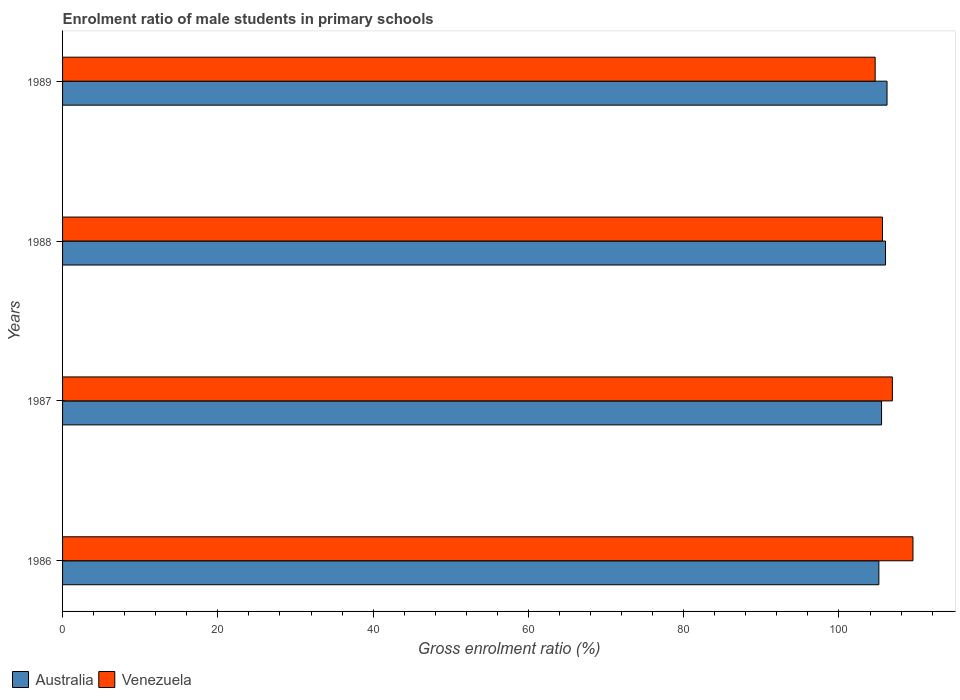How many bars are there on the 2nd tick from the bottom?
Keep it short and to the point. 2. What is the enrolment ratio of male students in primary schools in Australia in 1989?
Your response must be concise. 106.19. Across all years, what is the maximum enrolment ratio of male students in primary schools in Venezuela?
Your response must be concise. 109.53. Across all years, what is the minimum enrolment ratio of male students in primary schools in Australia?
Make the answer very short. 105.14. In which year was the enrolment ratio of male students in primary schools in Australia maximum?
Offer a very short reply. 1989. In which year was the enrolment ratio of male students in primary schools in Venezuela minimum?
Give a very brief answer. 1989. What is the total enrolment ratio of male students in primary schools in Venezuela in the graph?
Your response must be concise. 426.68. What is the difference between the enrolment ratio of male students in primary schools in Australia in 1986 and that in 1988?
Ensure brevity in your answer.  -0.86. What is the difference between the enrolment ratio of male students in primary schools in Australia in 1989 and the enrolment ratio of male students in primary schools in Venezuela in 1986?
Your answer should be compact. -3.34. What is the average enrolment ratio of male students in primary schools in Venezuela per year?
Offer a very short reply. 106.67. In the year 1988, what is the difference between the enrolment ratio of male students in primary schools in Venezuela and enrolment ratio of male students in primary schools in Australia?
Your response must be concise. -0.39. In how many years, is the enrolment ratio of male students in primary schools in Australia greater than 68 %?
Give a very brief answer. 4. What is the ratio of the enrolment ratio of male students in primary schools in Australia in 1986 to that in 1987?
Your answer should be very brief. 1. Is the enrolment ratio of male students in primary schools in Australia in 1986 less than that in 1989?
Keep it short and to the point. Yes. Is the difference between the enrolment ratio of male students in primary schools in Venezuela in 1987 and 1989 greater than the difference between the enrolment ratio of male students in primary schools in Australia in 1987 and 1989?
Give a very brief answer. Yes. What is the difference between the highest and the second highest enrolment ratio of male students in primary schools in Australia?
Make the answer very short. 0.2. What is the difference between the highest and the lowest enrolment ratio of male students in primary schools in Venezuela?
Give a very brief answer. 4.87. What does the 1st bar from the top in 1988 represents?
Offer a terse response. Venezuela. How many bars are there?
Provide a succinct answer. 8. Are all the bars in the graph horizontal?
Offer a very short reply. Yes. What is the difference between two consecutive major ticks on the X-axis?
Offer a terse response. 20. Are the values on the major ticks of X-axis written in scientific E-notation?
Your response must be concise. No. Does the graph contain grids?
Provide a short and direct response. No. How many legend labels are there?
Ensure brevity in your answer.  2. How are the legend labels stacked?
Your response must be concise. Horizontal. What is the title of the graph?
Your response must be concise. Enrolment ratio of male students in primary schools. Does "Japan" appear as one of the legend labels in the graph?
Offer a very short reply. No. What is the label or title of the X-axis?
Make the answer very short. Gross enrolment ratio (%). What is the Gross enrolment ratio (%) of Australia in 1986?
Offer a very short reply. 105.14. What is the Gross enrolment ratio (%) in Venezuela in 1986?
Make the answer very short. 109.53. What is the Gross enrolment ratio (%) in Australia in 1987?
Offer a very short reply. 105.49. What is the Gross enrolment ratio (%) in Venezuela in 1987?
Keep it short and to the point. 106.88. What is the Gross enrolment ratio (%) of Australia in 1988?
Offer a very short reply. 105.99. What is the Gross enrolment ratio (%) in Venezuela in 1988?
Provide a succinct answer. 105.6. What is the Gross enrolment ratio (%) in Australia in 1989?
Make the answer very short. 106.19. What is the Gross enrolment ratio (%) of Venezuela in 1989?
Provide a short and direct response. 104.66. Across all years, what is the maximum Gross enrolment ratio (%) of Australia?
Ensure brevity in your answer.  106.19. Across all years, what is the maximum Gross enrolment ratio (%) in Venezuela?
Your response must be concise. 109.53. Across all years, what is the minimum Gross enrolment ratio (%) in Australia?
Your answer should be compact. 105.14. Across all years, what is the minimum Gross enrolment ratio (%) in Venezuela?
Provide a short and direct response. 104.66. What is the total Gross enrolment ratio (%) of Australia in the graph?
Offer a terse response. 422.81. What is the total Gross enrolment ratio (%) in Venezuela in the graph?
Give a very brief answer. 426.68. What is the difference between the Gross enrolment ratio (%) of Australia in 1986 and that in 1987?
Offer a terse response. -0.35. What is the difference between the Gross enrolment ratio (%) in Venezuela in 1986 and that in 1987?
Offer a terse response. 2.65. What is the difference between the Gross enrolment ratio (%) of Australia in 1986 and that in 1988?
Offer a terse response. -0.86. What is the difference between the Gross enrolment ratio (%) of Venezuela in 1986 and that in 1988?
Provide a succinct answer. 3.93. What is the difference between the Gross enrolment ratio (%) of Australia in 1986 and that in 1989?
Your answer should be very brief. -1.05. What is the difference between the Gross enrolment ratio (%) of Venezuela in 1986 and that in 1989?
Offer a very short reply. 4.87. What is the difference between the Gross enrolment ratio (%) of Australia in 1987 and that in 1988?
Offer a terse response. -0.51. What is the difference between the Gross enrolment ratio (%) of Venezuela in 1987 and that in 1988?
Offer a terse response. 1.27. What is the difference between the Gross enrolment ratio (%) of Australia in 1987 and that in 1989?
Provide a short and direct response. -0.7. What is the difference between the Gross enrolment ratio (%) in Venezuela in 1987 and that in 1989?
Provide a succinct answer. 2.22. What is the difference between the Gross enrolment ratio (%) of Australia in 1988 and that in 1989?
Your response must be concise. -0.2. What is the difference between the Gross enrolment ratio (%) of Venezuela in 1988 and that in 1989?
Your answer should be compact. 0.94. What is the difference between the Gross enrolment ratio (%) of Australia in 1986 and the Gross enrolment ratio (%) of Venezuela in 1987?
Your answer should be compact. -1.74. What is the difference between the Gross enrolment ratio (%) of Australia in 1986 and the Gross enrolment ratio (%) of Venezuela in 1988?
Your response must be concise. -0.46. What is the difference between the Gross enrolment ratio (%) of Australia in 1986 and the Gross enrolment ratio (%) of Venezuela in 1989?
Make the answer very short. 0.48. What is the difference between the Gross enrolment ratio (%) in Australia in 1987 and the Gross enrolment ratio (%) in Venezuela in 1988?
Keep it short and to the point. -0.12. What is the difference between the Gross enrolment ratio (%) of Australia in 1987 and the Gross enrolment ratio (%) of Venezuela in 1989?
Your response must be concise. 0.83. What is the difference between the Gross enrolment ratio (%) in Australia in 1988 and the Gross enrolment ratio (%) in Venezuela in 1989?
Give a very brief answer. 1.33. What is the average Gross enrolment ratio (%) of Australia per year?
Make the answer very short. 105.7. What is the average Gross enrolment ratio (%) of Venezuela per year?
Give a very brief answer. 106.67. In the year 1986, what is the difference between the Gross enrolment ratio (%) of Australia and Gross enrolment ratio (%) of Venezuela?
Ensure brevity in your answer.  -4.39. In the year 1987, what is the difference between the Gross enrolment ratio (%) of Australia and Gross enrolment ratio (%) of Venezuela?
Offer a very short reply. -1.39. In the year 1988, what is the difference between the Gross enrolment ratio (%) of Australia and Gross enrolment ratio (%) of Venezuela?
Give a very brief answer. 0.39. In the year 1989, what is the difference between the Gross enrolment ratio (%) of Australia and Gross enrolment ratio (%) of Venezuela?
Provide a succinct answer. 1.53. What is the ratio of the Gross enrolment ratio (%) of Venezuela in 1986 to that in 1987?
Your answer should be compact. 1.02. What is the ratio of the Gross enrolment ratio (%) of Venezuela in 1986 to that in 1988?
Your answer should be compact. 1.04. What is the ratio of the Gross enrolment ratio (%) in Australia in 1986 to that in 1989?
Your answer should be very brief. 0.99. What is the ratio of the Gross enrolment ratio (%) in Venezuela in 1986 to that in 1989?
Your response must be concise. 1.05. What is the ratio of the Gross enrolment ratio (%) in Australia in 1987 to that in 1988?
Offer a very short reply. 1. What is the ratio of the Gross enrolment ratio (%) in Venezuela in 1987 to that in 1988?
Provide a succinct answer. 1.01. What is the ratio of the Gross enrolment ratio (%) of Australia in 1987 to that in 1989?
Your response must be concise. 0.99. What is the ratio of the Gross enrolment ratio (%) in Venezuela in 1987 to that in 1989?
Provide a succinct answer. 1.02. What is the difference between the highest and the second highest Gross enrolment ratio (%) of Australia?
Offer a very short reply. 0.2. What is the difference between the highest and the second highest Gross enrolment ratio (%) of Venezuela?
Give a very brief answer. 2.65. What is the difference between the highest and the lowest Gross enrolment ratio (%) in Australia?
Ensure brevity in your answer.  1.05. What is the difference between the highest and the lowest Gross enrolment ratio (%) in Venezuela?
Make the answer very short. 4.87. 